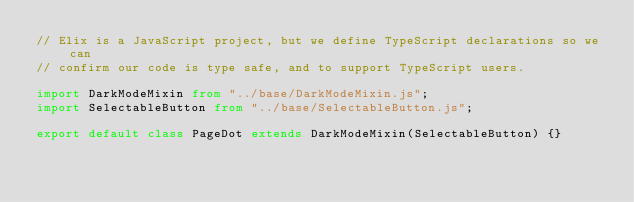Convert code to text. <code><loc_0><loc_0><loc_500><loc_500><_TypeScript_>// Elix is a JavaScript project, but we define TypeScript declarations so we can
// confirm our code is type safe, and to support TypeScript users.

import DarkModeMixin from "../base/DarkModeMixin.js";
import SelectableButton from "../base/SelectableButton.js";

export default class PageDot extends DarkModeMixin(SelectableButton) {}
</code> 